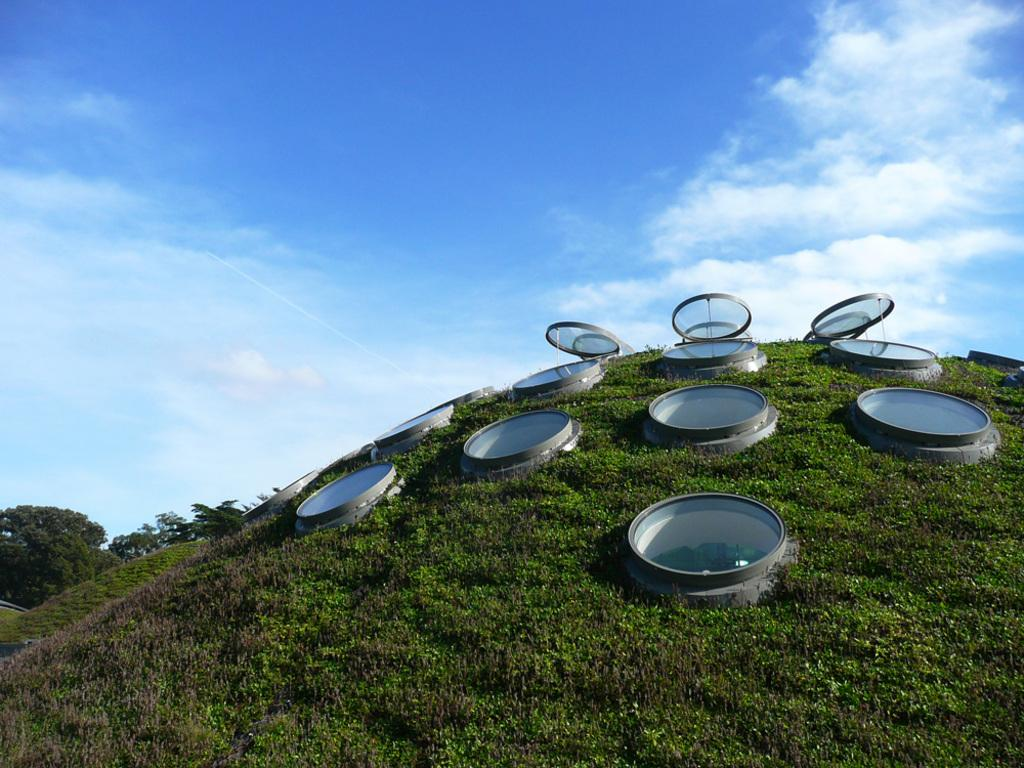What type of clothing accessory is present in the image? There are caps in the image. What is the hole in the image? The hole is a feature in the image, but its purpose or context is not clear from the facts provided. What type of vegetation is visible in the image? Grass is visible in the image. What is visible at the top of the image? The sky is visible at the top of the image. What is located on the left side of the image? There are trees on the left side of the image. What type of humor can be seen in the image? There is no humor present in the image; it features caps, a hole, grass, the sky, and trees. Where is the playground located in the image? There is no playground present in the image. 